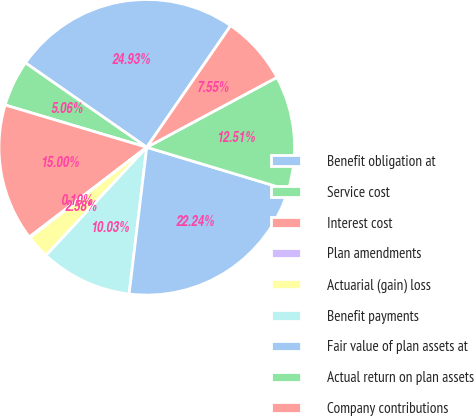<chart> <loc_0><loc_0><loc_500><loc_500><pie_chart><fcel>Benefit obligation at<fcel>Service cost<fcel>Interest cost<fcel>Plan amendments<fcel>Actuarial (gain) loss<fcel>Benefit payments<fcel>Fair value of plan assets at<fcel>Actual return on plan assets<fcel>Company contributions<nl><fcel>24.93%<fcel>5.06%<fcel>15.0%<fcel>0.1%<fcel>2.58%<fcel>10.03%<fcel>22.24%<fcel>12.51%<fcel>7.55%<nl></chart> 